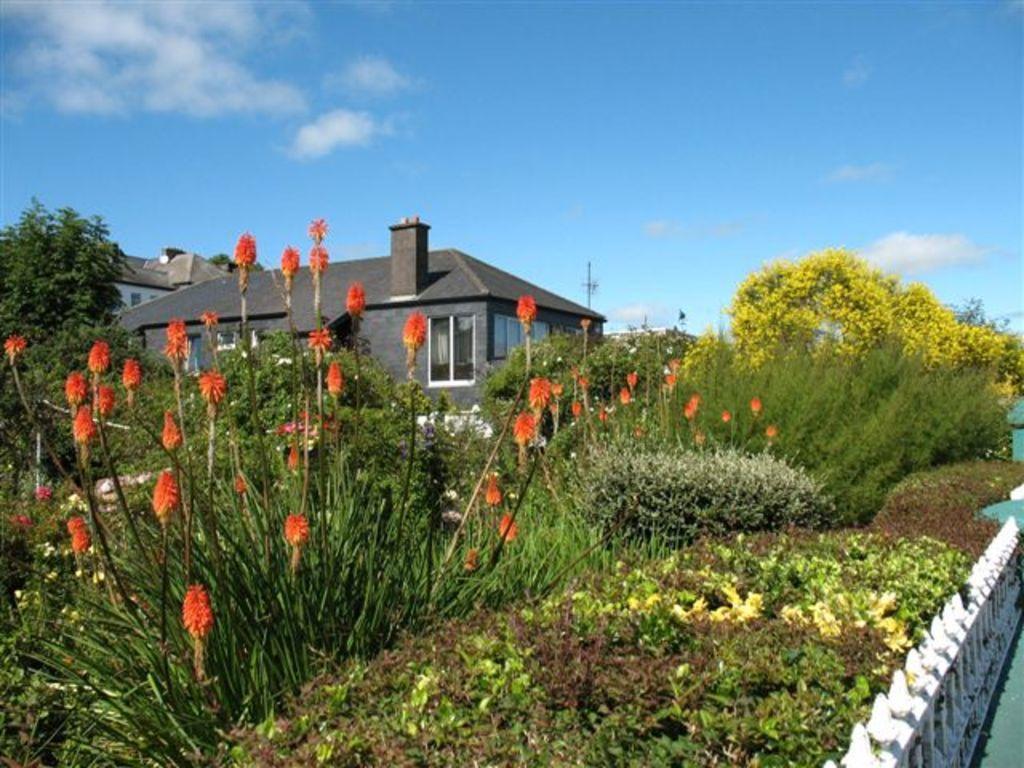Can you describe this image briefly? In this picture I can see there are variety of plants and flowers and there are trees and in the backdrop there is a building and the sky is clear. 